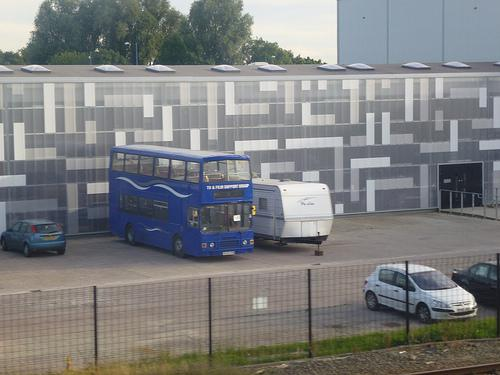Question: how many vehicles are there?
Choices:
A. 1.
B. 2.
C. 4.
D. 3.
Answer with the letter. Answer: C Question: what color is parking lot?
Choices:
A. Black.
B. Brown.
C. Green.
D. Grey.
Answer with the letter. Answer: D Question: when was picture taken?
Choices:
A. Nighttime.
B. Morning.
C. Evening.
D. Daytime.
Answer with the letter. Answer: C Question: where was picture taken?
Choices:
A. Close to train.
B. Close to subway.
C. Close to plane.
D. Close to a bus.
Answer with the letter. Answer: D 